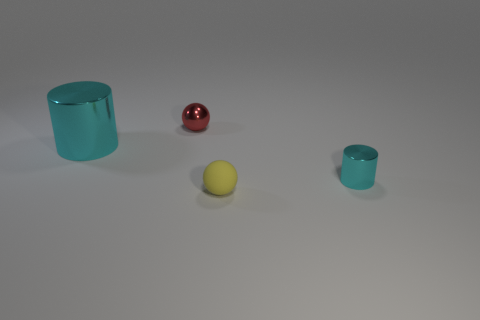Subtract 1 cylinders. How many cylinders are left? 1 Subtract all red balls. How many balls are left? 1 Subtract all purple balls. Subtract all brown cylinders. How many balls are left? 2 Subtract all purple blocks. How many yellow spheres are left? 1 Subtract all big gray metallic cylinders. Subtract all tiny cyan cylinders. How many objects are left? 3 Add 1 small metallic things. How many small metallic things are left? 3 Add 1 big shiny objects. How many big shiny objects exist? 2 Add 3 tiny gray matte spheres. How many objects exist? 7 Subtract 0 gray cubes. How many objects are left? 4 